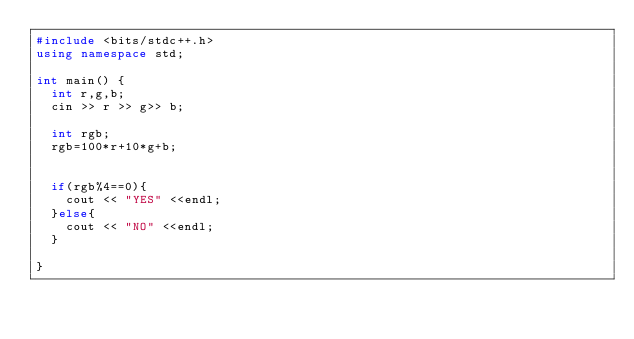<code> <loc_0><loc_0><loc_500><loc_500><_C++_>#include <bits/stdc++.h>
using namespace std;
 
int main() {
  int r,g,b;
  cin >> r >> g>> b;
  
  int rgb;
  rgb=100*r+10*g+b;
  
  
  if(rgb%4==0){
    cout << "YES" <<endl;
  }else{
    cout << "NO" <<endl;
  }
  
}</code> 